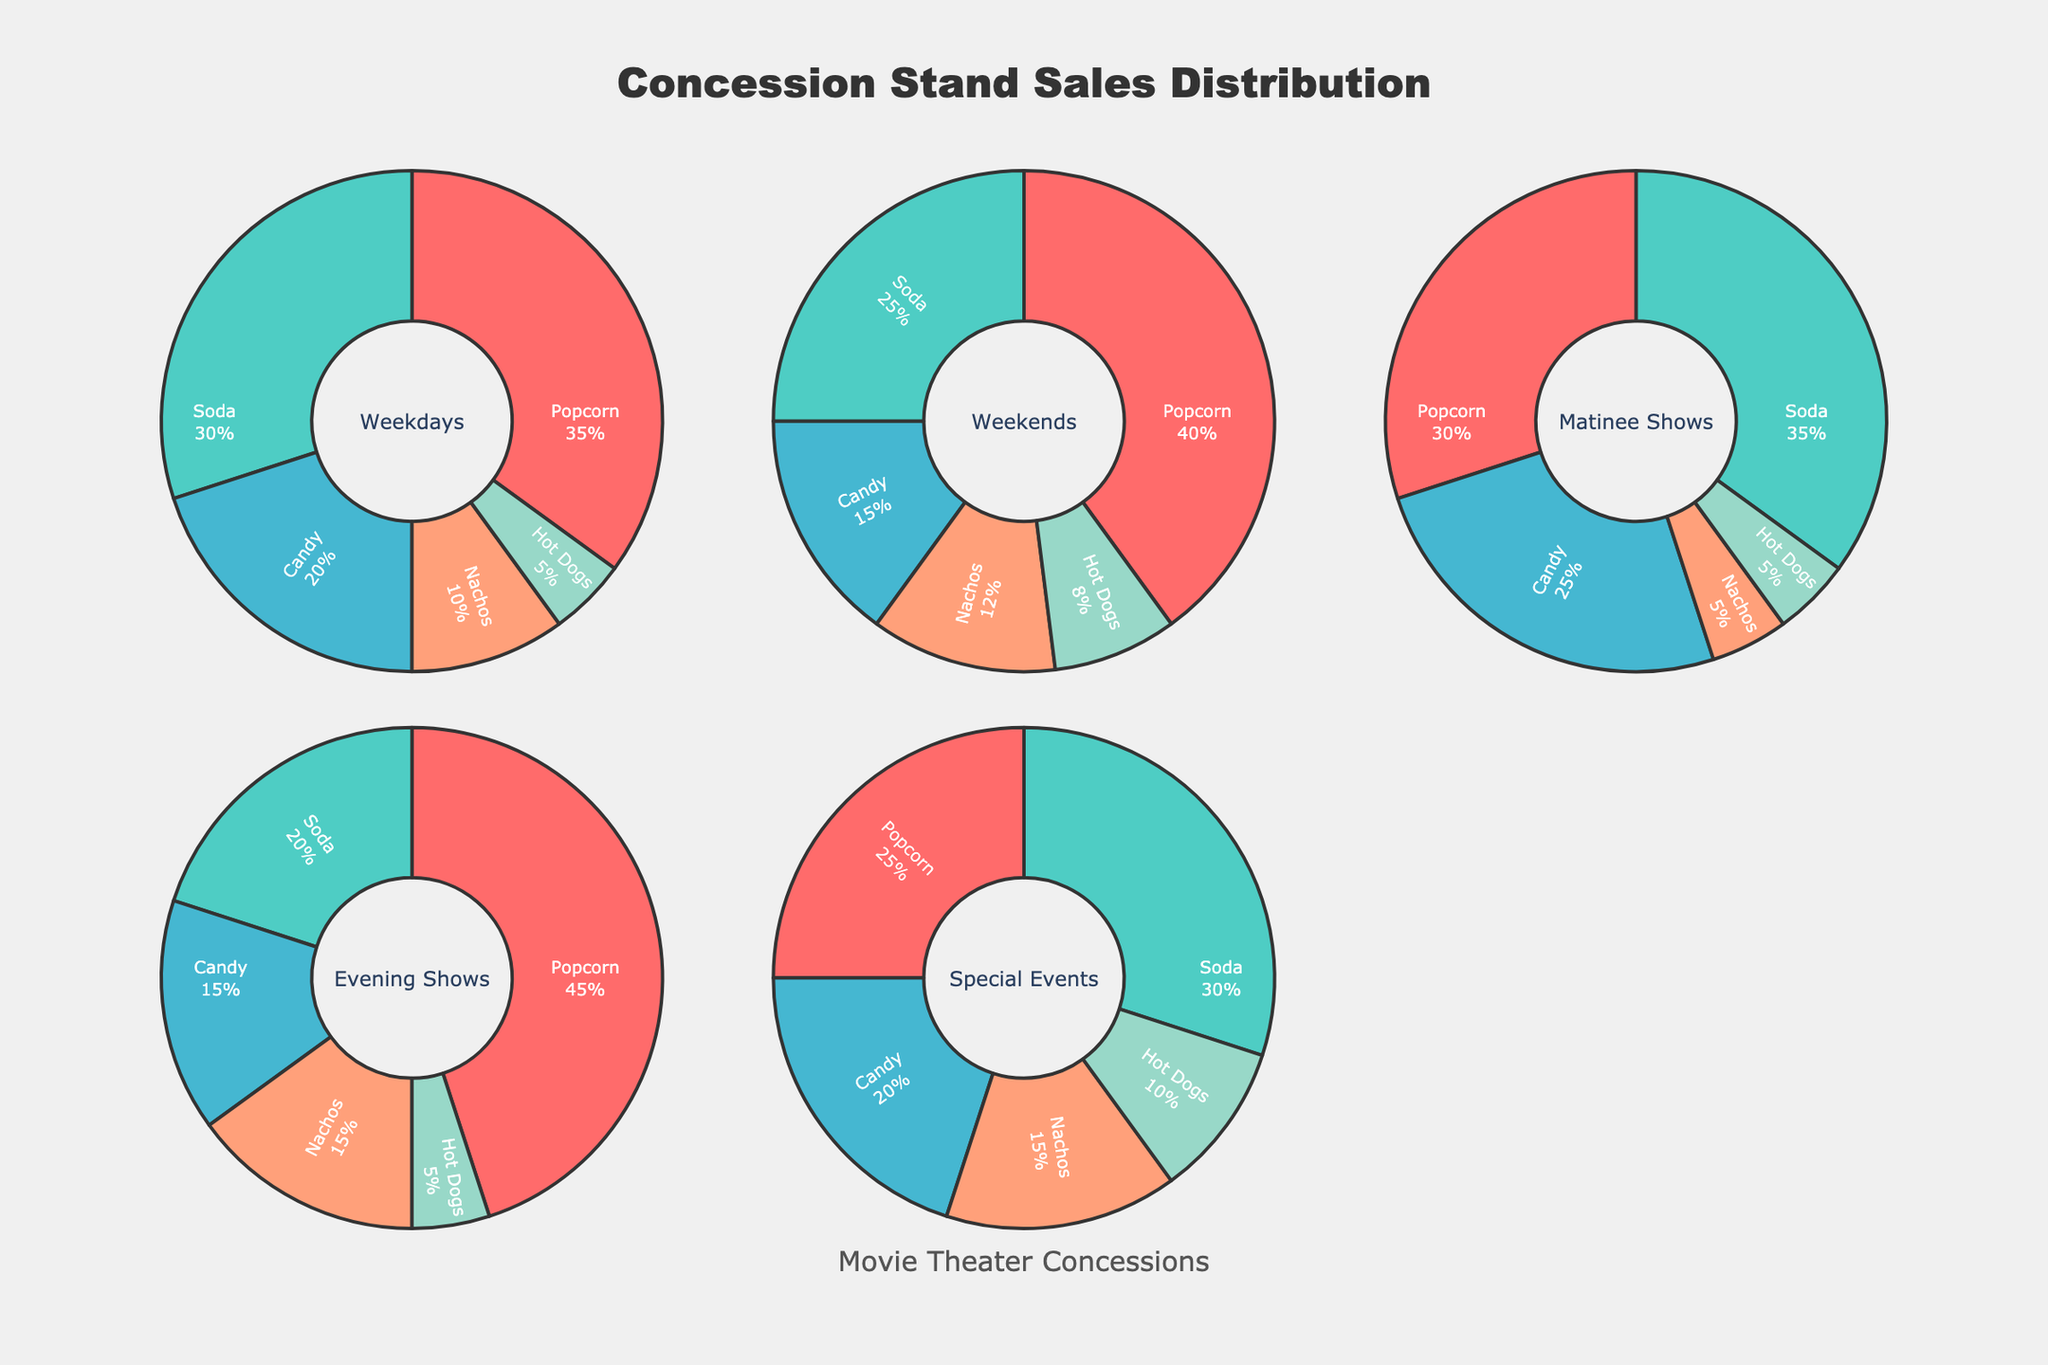What's the largest item category for Evening Shows? Look at the pie chart labeled "Evening Shows" and find the item category that has the largest percentage.
Answer: Popcorn Which item category has a higher percentage on Weekends compared to Weekdays? Compare the percentages of each item category on both Weekdays and Weekends pie charts. The largest percentage increase is for Nachos (12% on Weekends vs. 10% on Weekdays).
Answer: Nachos What is the total percentage of soda sales for Matinee Shows and Special Events combined? Check the pie charts for Matinee Shows and Special Events. Soda sales are 35% for Matinee Shows and 30% for Special Events, so sum these percentages: 35% + 30% = 65%.
Answer: 65% Which category has the smallest percentage share in Matinee Shows? Look at the Matinee Shows pie chart and identify the item category with the smallest share, which is Hot Dogs at 5%.
Answer: Hot Dogs How does the percentage of Candy sales on Weekdays compare with Candy sales during Special Events? Find the Candy percentage on both Weekdays (20%) and Special Events (20%); they are equal.
Answer: Equal For what category is the percentage distribution most consistent across all five conditions? Examine and compare the pie charts for each condition. Popcorn has the most consistent distribution, fluctuating between 25% and 45%.
Answer: Popcorn Which pie chart shows the highest percentage for Soda sales? Look at all the pie charts and see which has the highest Soda percentage. Matinee Shows have 35%, the highest among all charts.
Answer: Matinee Shows Compare the percentage of Nachos sales in Evening Shows with Hot Dogs sales in Weekends. Which one is higher? Nachos in Evening Shows have 15%, and Hot Dogs in Weekends have 8%. Therefore, Nachos in Evening Shows are higher.
Answer: Nachos in Evening Shows What's the difference in the percentage of Popcorn sales between Weekends and Evening Shows? Check the percentages of Popcorn in Weekends (40%) and Evening Shows (45%) and find the difference: 45% - 40% = 5%.
Answer: 5% 